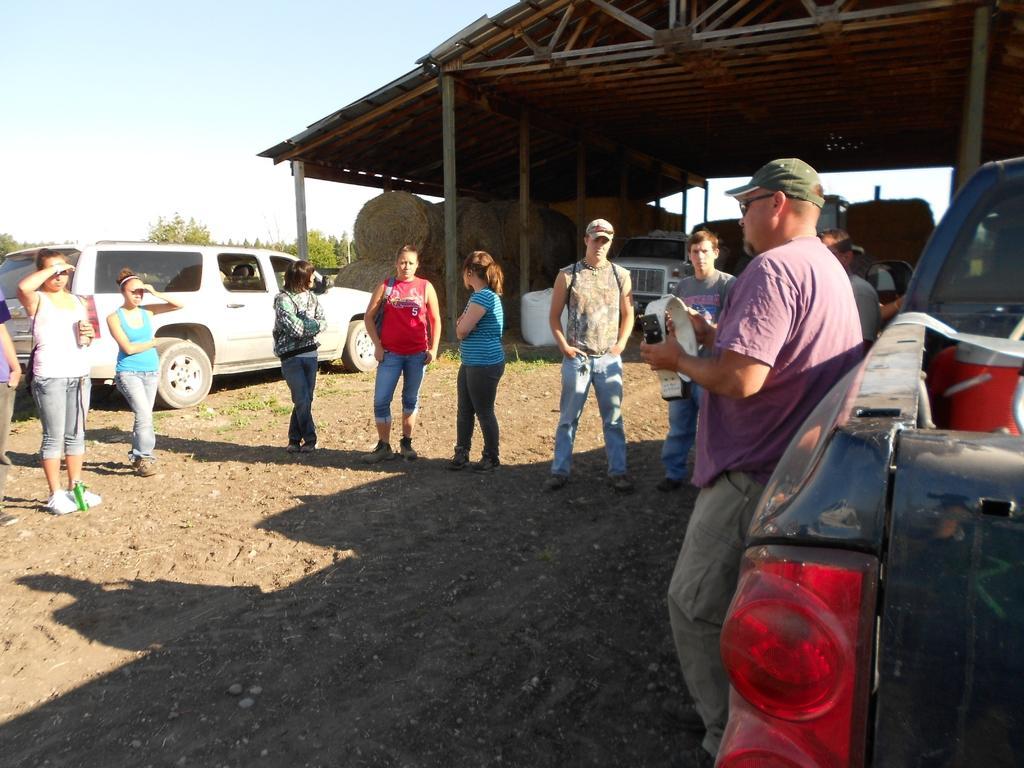Please provide a concise description of this image. In this image I see few people who are standing and I see the mud and I see 3 vehicles and I see that these 2 men are wearing caps and in the background I see the shed over here and I see hay over here and I see number of trees and the clear sky. 